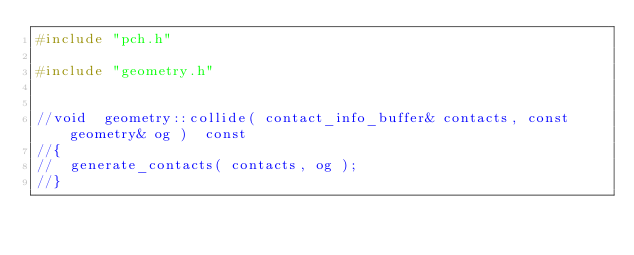Convert code to text. <code><loc_0><loc_0><loc_500><loc_500><_C++_>#include "pch.h"

#include "geometry.h"


//void	geometry::collide( contact_info_buffer& contacts, const geometry& og )	const
//{
//	generate_contacts( contacts, og );
//}</code> 